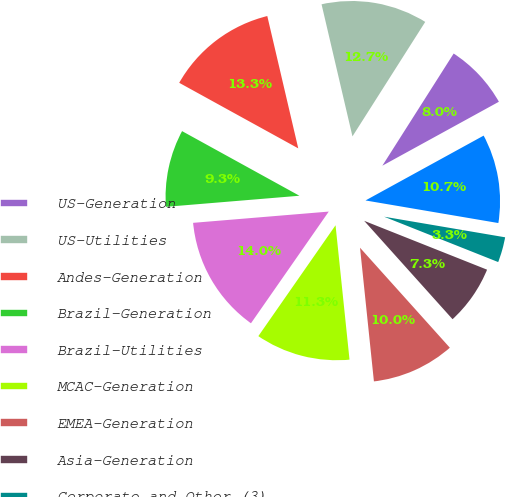Convert chart. <chart><loc_0><loc_0><loc_500><loc_500><pie_chart><fcel>US-Generation<fcel>US-Utilities<fcel>Andes-Generation<fcel>Brazil-Generation<fcel>Brazil-Utilities<fcel>MCAC-Generation<fcel>EMEA-Generation<fcel>Asia-Generation<fcel>Corporate and Other (3)<fcel>Interest expense<nl><fcel>8.0%<fcel>12.67%<fcel>13.33%<fcel>9.33%<fcel>14.0%<fcel>11.33%<fcel>10.0%<fcel>7.33%<fcel>3.34%<fcel>10.67%<nl></chart> 